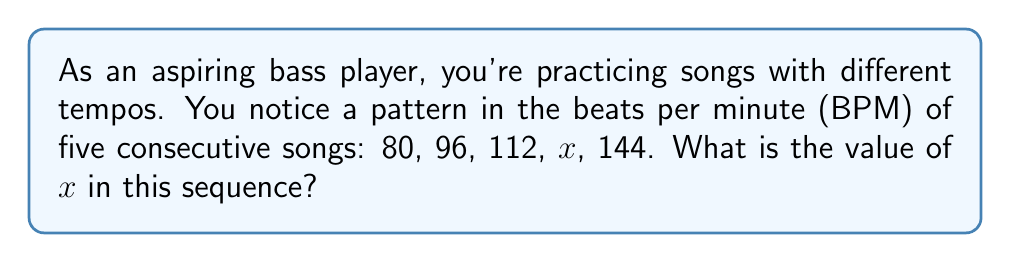Help me with this question. Let's approach this step-by-step:

1) First, we need to identify the pattern in the sequence. Let's look at the differences between consecutive terms:

   80 to 96: Increase of 16
   96 to 112: Increase of 16
   112 to $x$: Unknown
   $x$ to 144: Unknown

2) We can see that the first two intervals have a consistent increase of 16 BPM.

3) Assuming this pattern continues, we can set up an equation:

   $$112 + 16 = x$$

4) Solving this equation:

   $$x = 128$$

5) To verify, let's check if this maintains the pattern:

   80, 96, 112, 128, 144

   Indeed, the difference between each term is consistently 16 BPM.

6) This pattern makes sense musically, as each song is 16 BPM faster than the previous one, creating a gradual increase in tempo across the set list.
Answer: 128 